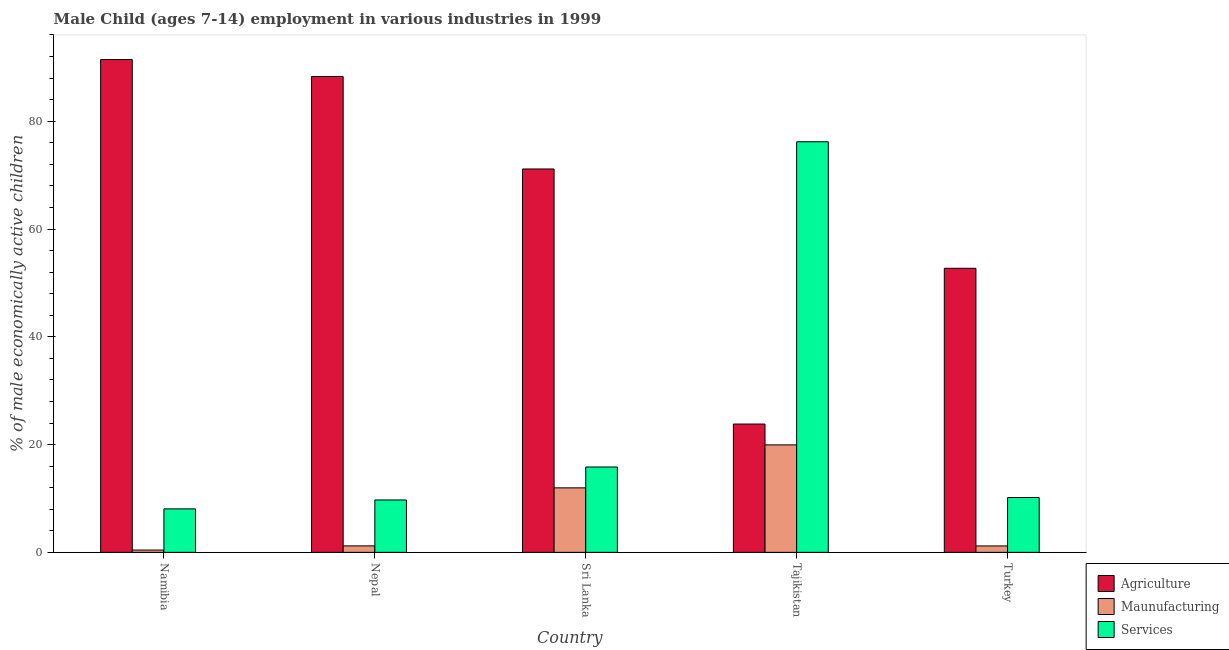How many different coloured bars are there?
Provide a short and direct response. 3. How many groups of bars are there?
Make the answer very short. 5. Are the number of bars on each tick of the X-axis equal?
Make the answer very short. Yes. How many bars are there on the 2nd tick from the left?
Provide a succinct answer. 3. What is the label of the 1st group of bars from the left?
Make the answer very short. Namibia. What is the percentage of economically active children in services in Nepal?
Offer a terse response. 9.72. Across all countries, what is the maximum percentage of economically active children in agriculture?
Offer a very short reply. 91.45. Across all countries, what is the minimum percentage of economically active children in agriculture?
Offer a very short reply. 23.81. In which country was the percentage of economically active children in services maximum?
Keep it short and to the point. Tajikistan. In which country was the percentage of economically active children in services minimum?
Provide a short and direct response. Namibia. What is the total percentage of economically active children in agriculture in the graph?
Give a very brief answer. 327.41. What is the difference between the percentage of economically active children in services in Namibia and that in Tajikistan?
Provide a succinct answer. -68.12. What is the difference between the percentage of economically active children in agriculture in Tajikistan and the percentage of economically active children in services in Turkey?
Give a very brief answer. 13.63. What is the average percentage of economically active children in manufacturing per country?
Keep it short and to the point. 6.95. What is the difference between the percentage of economically active children in services and percentage of economically active children in agriculture in Nepal?
Give a very brief answer. -78.58. In how many countries, is the percentage of economically active children in agriculture greater than 28 %?
Provide a succinct answer. 4. What is the ratio of the percentage of economically active children in services in Namibia to that in Turkey?
Offer a terse response. 0.79. Is the difference between the percentage of economically active children in agriculture in Namibia and Turkey greater than the difference between the percentage of economically active children in services in Namibia and Turkey?
Offer a very short reply. Yes. What is the difference between the highest and the second highest percentage of economically active children in agriculture?
Offer a very short reply. 3.15. What is the difference between the highest and the lowest percentage of economically active children in services?
Your answer should be compact. 68.12. In how many countries, is the percentage of economically active children in services greater than the average percentage of economically active children in services taken over all countries?
Make the answer very short. 1. What does the 2nd bar from the left in Tajikistan represents?
Offer a terse response. Maunufacturing. What does the 3rd bar from the right in Namibia represents?
Your answer should be very brief. Agriculture. How many bars are there?
Keep it short and to the point. 15. What is the difference between two consecutive major ticks on the Y-axis?
Keep it short and to the point. 20. Does the graph contain any zero values?
Your response must be concise. No. Where does the legend appear in the graph?
Provide a short and direct response. Bottom right. How are the legend labels stacked?
Keep it short and to the point. Vertical. What is the title of the graph?
Provide a succinct answer. Male Child (ages 7-14) employment in various industries in 1999. What is the label or title of the X-axis?
Make the answer very short. Country. What is the label or title of the Y-axis?
Keep it short and to the point. % of male economically active children. What is the % of male economically active children of Agriculture in Namibia?
Offer a very short reply. 91.45. What is the % of male economically active children in Maunufacturing in Namibia?
Keep it short and to the point. 0.43. What is the % of male economically active children of Services in Namibia?
Ensure brevity in your answer.  8.07. What is the % of male economically active children of Agriculture in Nepal?
Provide a short and direct response. 88.3. What is the % of male economically active children in Maunufacturing in Nepal?
Provide a succinct answer. 1.2. What is the % of male economically active children in Services in Nepal?
Provide a short and direct response. 9.72. What is the % of male economically active children of Agriculture in Sri Lanka?
Offer a terse response. 71.14. What is the % of male economically active children in Maunufacturing in Sri Lanka?
Provide a short and direct response. 11.97. What is the % of male economically active children in Services in Sri Lanka?
Offer a terse response. 15.84. What is the % of male economically active children of Agriculture in Tajikistan?
Your response must be concise. 23.81. What is the % of male economically active children in Maunufacturing in Tajikistan?
Keep it short and to the point. 19.94. What is the % of male economically active children in Services in Tajikistan?
Your answer should be compact. 76.19. What is the % of male economically active children of Agriculture in Turkey?
Keep it short and to the point. 52.71. What is the % of male economically active children of Maunufacturing in Turkey?
Your answer should be compact. 1.19. What is the % of male economically active children in Services in Turkey?
Your answer should be compact. 10.18. Across all countries, what is the maximum % of male economically active children in Agriculture?
Offer a terse response. 91.45. Across all countries, what is the maximum % of male economically active children in Maunufacturing?
Your answer should be compact. 19.94. Across all countries, what is the maximum % of male economically active children of Services?
Offer a very short reply. 76.19. Across all countries, what is the minimum % of male economically active children in Agriculture?
Give a very brief answer. 23.81. Across all countries, what is the minimum % of male economically active children in Maunufacturing?
Provide a succinct answer. 0.43. Across all countries, what is the minimum % of male economically active children in Services?
Offer a very short reply. 8.07. What is the total % of male economically active children of Agriculture in the graph?
Provide a succinct answer. 327.41. What is the total % of male economically active children in Maunufacturing in the graph?
Give a very brief answer. 34.74. What is the total % of male economically active children of Services in the graph?
Ensure brevity in your answer.  120. What is the difference between the % of male economically active children of Agriculture in Namibia and that in Nepal?
Offer a terse response. 3.15. What is the difference between the % of male economically active children in Maunufacturing in Namibia and that in Nepal?
Your answer should be compact. -0.77. What is the difference between the % of male economically active children of Services in Namibia and that in Nepal?
Ensure brevity in your answer.  -1.65. What is the difference between the % of male economically active children of Agriculture in Namibia and that in Sri Lanka?
Your response must be concise. 20.31. What is the difference between the % of male economically active children of Maunufacturing in Namibia and that in Sri Lanka?
Make the answer very short. -11.54. What is the difference between the % of male economically active children of Services in Namibia and that in Sri Lanka?
Give a very brief answer. -7.77. What is the difference between the % of male economically active children in Agriculture in Namibia and that in Tajikistan?
Give a very brief answer. 67.64. What is the difference between the % of male economically active children of Maunufacturing in Namibia and that in Tajikistan?
Offer a very short reply. -19.51. What is the difference between the % of male economically active children in Services in Namibia and that in Tajikistan?
Your answer should be very brief. -68.12. What is the difference between the % of male economically active children of Agriculture in Namibia and that in Turkey?
Offer a very short reply. 38.74. What is the difference between the % of male economically active children in Maunufacturing in Namibia and that in Turkey?
Give a very brief answer. -0.76. What is the difference between the % of male economically active children of Services in Namibia and that in Turkey?
Offer a terse response. -2.11. What is the difference between the % of male economically active children of Agriculture in Nepal and that in Sri Lanka?
Offer a terse response. 17.16. What is the difference between the % of male economically active children of Maunufacturing in Nepal and that in Sri Lanka?
Your response must be concise. -10.77. What is the difference between the % of male economically active children in Services in Nepal and that in Sri Lanka?
Ensure brevity in your answer.  -6.12. What is the difference between the % of male economically active children of Agriculture in Nepal and that in Tajikistan?
Give a very brief answer. 64.49. What is the difference between the % of male economically active children in Maunufacturing in Nepal and that in Tajikistan?
Offer a terse response. -18.74. What is the difference between the % of male economically active children of Services in Nepal and that in Tajikistan?
Provide a short and direct response. -66.47. What is the difference between the % of male economically active children of Agriculture in Nepal and that in Turkey?
Your answer should be very brief. 35.59. What is the difference between the % of male economically active children of Maunufacturing in Nepal and that in Turkey?
Give a very brief answer. 0.01. What is the difference between the % of male economically active children of Services in Nepal and that in Turkey?
Provide a short and direct response. -0.45. What is the difference between the % of male economically active children of Agriculture in Sri Lanka and that in Tajikistan?
Offer a very short reply. 47.33. What is the difference between the % of male economically active children in Maunufacturing in Sri Lanka and that in Tajikistan?
Your answer should be compact. -7.97. What is the difference between the % of male economically active children in Services in Sri Lanka and that in Tajikistan?
Your answer should be very brief. -60.35. What is the difference between the % of male economically active children of Agriculture in Sri Lanka and that in Turkey?
Offer a terse response. 18.43. What is the difference between the % of male economically active children of Maunufacturing in Sri Lanka and that in Turkey?
Make the answer very short. 10.78. What is the difference between the % of male economically active children of Services in Sri Lanka and that in Turkey?
Provide a succinct answer. 5.66. What is the difference between the % of male economically active children of Agriculture in Tajikistan and that in Turkey?
Keep it short and to the point. -28.9. What is the difference between the % of male economically active children of Maunufacturing in Tajikistan and that in Turkey?
Offer a terse response. 18.75. What is the difference between the % of male economically active children in Services in Tajikistan and that in Turkey?
Offer a very short reply. 66.01. What is the difference between the % of male economically active children in Agriculture in Namibia and the % of male economically active children in Maunufacturing in Nepal?
Give a very brief answer. 90.25. What is the difference between the % of male economically active children in Agriculture in Namibia and the % of male economically active children in Services in Nepal?
Make the answer very short. 81.73. What is the difference between the % of male economically active children in Maunufacturing in Namibia and the % of male economically active children in Services in Nepal?
Keep it short and to the point. -9.29. What is the difference between the % of male economically active children of Agriculture in Namibia and the % of male economically active children of Maunufacturing in Sri Lanka?
Ensure brevity in your answer.  79.48. What is the difference between the % of male economically active children of Agriculture in Namibia and the % of male economically active children of Services in Sri Lanka?
Provide a succinct answer. 75.61. What is the difference between the % of male economically active children of Maunufacturing in Namibia and the % of male economically active children of Services in Sri Lanka?
Ensure brevity in your answer.  -15.41. What is the difference between the % of male economically active children of Agriculture in Namibia and the % of male economically active children of Maunufacturing in Tajikistan?
Make the answer very short. 71.51. What is the difference between the % of male economically active children in Agriculture in Namibia and the % of male economically active children in Services in Tajikistan?
Provide a succinct answer. 15.26. What is the difference between the % of male economically active children of Maunufacturing in Namibia and the % of male economically active children of Services in Tajikistan?
Keep it short and to the point. -75.76. What is the difference between the % of male economically active children in Agriculture in Namibia and the % of male economically active children in Maunufacturing in Turkey?
Your answer should be compact. 90.26. What is the difference between the % of male economically active children in Agriculture in Namibia and the % of male economically active children in Services in Turkey?
Your response must be concise. 81.27. What is the difference between the % of male economically active children of Maunufacturing in Namibia and the % of male economically active children of Services in Turkey?
Keep it short and to the point. -9.75. What is the difference between the % of male economically active children of Agriculture in Nepal and the % of male economically active children of Maunufacturing in Sri Lanka?
Your answer should be very brief. 76.33. What is the difference between the % of male economically active children of Agriculture in Nepal and the % of male economically active children of Services in Sri Lanka?
Provide a succinct answer. 72.46. What is the difference between the % of male economically active children in Maunufacturing in Nepal and the % of male economically active children in Services in Sri Lanka?
Ensure brevity in your answer.  -14.64. What is the difference between the % of male economically active children in Agriculture in Nepal and the % of male economically active children in Maunufacturing in Tajikistan?
Provide a short and direct response. 68.36. What is the difference between the % of male economically active children of Agriculture in Nepal and the % of male economically active children of Services in Tajikistan?
Your response must be concise. 12.11. What is the difference between the % of male economically active children of Maunufacturing in Nepal and the % of male economically active children of Services in Tajikistan?
Your answer should be very brief. -74.99. What is the difference between the % of male economically active children in Agriculture in Nepal and the % of male economically active children in Maunufacturing in Turkey?
Provide a succinct answer. 87.11. What is the difference between the % of male economically active children of Agriculture in Nepal and the % of male economically active children of Services in Turkey?
Offer a terse response. 78.12. What is the difference between the % of male economically active children of Maunufacturing in Nepal and the % of male economically active children of Services in Turkey?
Offer a very short reply. -8.97. What is the difference between the % of male economically active children of Agriculture in Sri Lanka and the % of male economically active children of Maunufacturing in Tajikistan?
Keep it short and to the point. 51.2. What is the difference between the % of male economically active children in Agriculture in Sri Lanka and the % of male economically active children in Services in Tajikistan?
Offer a very short reply. -5.05. What is the difference between the % of male economically active children in Maunufacturing in Sri Lanka and the % of male economically active children in Services in Tajikistan?
Offer a terse response. -64.22. What is the difference between the % of male economically active children in Agriculture in Sri Lanka and the % of male economically active children in Maunufacturing in Turkey?
Offer a very short reply. 69.95. What is the difference between the % of male economically active children of Agriculture in Sri Lanka and the % of male economically active children of Services in Turkey?
Keep it short and to the point. 60.96. What is the difference between the % of male economically active children of Maunufacturing in Sri Lanka and the % of male economically active children of Services in Turkey?
Keep it short and to the point. 1.79. What is the difference between the % of male economically active children of Agriculture in Tajikistan and the % of male economically active children of Maunufacturing in Turkey?
Offer a terse response. 22.62. What is the difference between the % of male economically active children in Agriculture in Tajikistan and the % of male economically active children in Services in Turkey?
Your answer should be compact. 13.63. What is the difference between the % of male economically active children in Maunufacturing in Tajikistan and the % of male economically active children in Services in Turkey?
Provide a short and direct response. 9.77. What is the average % of male economically active children of Agriculture per country?
Ensure brevity in your answer.  65.48. What is the average % of male economically active children in Maunufacturing per country?
Offer a very short reply. 6.95. What is the average % of male economically active children of Services per country?
Keep it short and to the point. 24. What is the difference between the % of male economically active children of Agriculture and % of male economically active children of Maunufacturing in Namibia?
Your answer should be compact. 91.02. What is the difference between the % of male economically active children in Agriculture and % of male economically active children in Services in Namibia?
Make the answer very short. 83.38. What is the difference between the % of male economically active children of Maunufacturing and % of male economically active children of Services in Namibia?
Your answer should be compact. -7.64. What is the difference between the % of male economically active children of Agriculture and % of male economically active children of Maunufacturing in Nepal?
Your answer should be compact. 87.1. What is the difference between the % of male economically active children of Agriculture and % of male economically active children of Services in Nepal?
Your answer should be compact. 78.58. What is the difference between the % of male economically active children of Maunufacturing and % of male economically active children of Services in Nepal?
Provide a short and direct response. -8.52. What is the difference between the % of male economically active children in Agriculture and % of male economically active children in Maunufacturing in Sri Lanka?
Your answer should be compact. 59.17. What is the difference between the % of male economically active children of Agriculture and % of male economically active children of Services in Sri Lanka?
Make the answer very short. 55.3. What is the difference between the % of male economically active children in Maunufacturing and % of male economically active children in Services in Sri Lanka?
Give a very brief answer. -3.87. What is the difference between the % of male economically active children of Agriculture and % of male economically active children of Maunufacturing in Tajikistan?
Provide a succinct answer. 3.87. What is the difference between the % of male economically active children of Agriculture and % of male economically active children of Services in Tajikistan?
Your answer should be very brief. -52.38. What is the difference between the % of male economically active children in Maunufacturing and % of male economically active children in Services in Tajikistan?
Keep it short and to the point. -56.25. What is the difference between the % of male economically active children in Agriculture and % of male economically active children in Maunufacturing in Turkey?
Make the answer very short. 51.52. What is the difference between the % of male economically active children in Agriculture and % of male economically active children in Services in Turkey?
Your answer should be compact. 42.53. What is the difference between the % of male economically active children in Maunufacturing and % of male economically active children in Services in Turkey?
Offer a terse response. -8.99. What is the ratio of the % of male economically active children in Agriculture in Namibia to that in Nepal?
Provide a short and direct response. 1.04. What is the ratio of the % of male economically active children of Maunufacturing in Namibia to that in Nepal?
Offer a very short reply. 0.36. What is the ratio of the % of male economically active children in Services in Namibia to that in Nepal?
Keep it short and to the point. 0.83. What is the ratio of the % of male economically active children in Agriculture in Namibia to that in Sri Lanka?
Offer a terse response. 1.29. What is the ratio of the % of male economically active children in Maunufacturing in Namibia to that in Sri Lanka?
Provide a short and direct response. 0.04. What is the ratio of the % of male economically active children of Services in Namibia to that in Sri Lanka?
Your response must be concise. 0.51. What is the ratio of the % of male economically active children in Agriculture in Namibia to that in Tajikistan?
Give a very brief answer. 3.84. What is the ratio of the % of male economically active children in Maunufacturing in Namibia to that in Tajikistan?
Provide a succinct answer. 0.02. What is the ratio of the % of male economically active children of Services in Namibia to that in Tajikistan?
Provide a short and direct response. 0.11. What is the ratio of the % of male economically active children of Agriculture in Namibia to that in Turkey?
Make the answer very short. 1.73. What is the ratio of the % of male economically active children in Maunufacturing in Namibia to that in Turkey?
Offer a very short reply. 0.36. What is the ratio of the % of male economically active children of Services in Namibia to that in Turkey?
Offer a terse response. 0.79. What is the ratio of the % of male economically active children in Agriculture in Nepal to that in Sri Lanka?
Provide a short and direct response. 1.24. What is the ratio of the % of male economically active children of Maunufacturing in Nepal to that in Sri Lanka?
Your response must be concise. 0.1. What is the ratio of the % of male economically active children in Services in Nepal to that in Sri Lanka?
Your response must be concise. 0.61. What is the ratio of the % of male economically active children of Agriculture in Nepal to that in Tajikistan?
Keep it short and to the point. 3.71. What is the ratio of the % of male economically active children in Maunufacturing in Nepal to that in Tajikistan?
Make the answer very short. 0.06. What is the ratio of the % of male economically active children of Services in Nepal to that in Tajikistan?
Ensure brevity in your answer.  0.13. What is the ratio of the % of male economically active children of Agriculture in Nepal to that in Turkey?
Your answer should be very brief. 1.68. What is the ratio of the % of male economically active children of Maunufacturing in Nepal to that in Turkey?
Keep it short and to the point. 1.01. What is the ratio of the % of male economically active children in Services in Nepal to that in Turkey?
Your answer should be very brief. 0.96. What is the ratio of the % of male economically active children in Agriculture in Sri Lanka to that in Tajikistan?
Offer a very short reply. 2.99. What is the ratio of the % of male economically active children in Maunufacturing in Sri Lanka to that in Tajikistan?
Your response must be concise. 0.6. What is the ratio of the % of male economically active children of Services in Sri Lanka to that in Tajikistan?
Your answer should be compact. 0.21. What is the ratio of the % of male economically active children of Agriculture in Sri Lanka to that in Turkey?
Offer a terse response. 1.35. What is the ratio of the % of male economically active children in Maunufacturing in Sri Lanka to that in Turkey?
Give a very brief answer. 10.06. What is the ratio of the % of male economically active children in Services in Sri Lanka to that in Turkey?
Your answer should be compact. 1.56. What is the ratio of the % of male economically active children of Agriculture in Tajikistan to that in Turkey?
Your answer should be compact. 0.45. What is the ratio of the % of male economically active children in Maunufacturing in Tajikistan to that in Turkey?
Keep it short and to the point. 16.76. What is the ratio of the % of male economically active children in Services in Tajikistan to that in Turkey?
Make the answer very short. 7.49. What is the difference between the highest and the second highest % of male economically active children in Agriculture?
Offer a terse response. 3.15. What is the difference between the highest and the second highest % of male economically active children in Maunufacturing?
Make the answer very short. 7.97. What is the difference between the highest and the second highest % of male economically active children in Services?
Your answer should be compact. 60.35. What is the difference between the highest and the lowest % of male economically active children in Agriculture?
Your answer should be very brief. 67.64. What is the difference between the highest and the lowest % of male economically active children of Maunufacturing?
Give a very brief answer. 19.51. What is the difference between the highest and the lowest % of male economically active children in Services?
Offer a terse response. 68.12. 